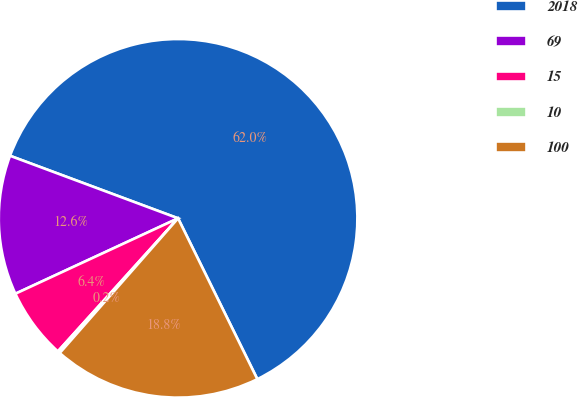Convert chart to OTSL. <chart><loc_0><loc_0><loc_500><loc_500><pie_chart><fcel>2018<fcel>69<fcel>15<fcel>10<fcel>100<nl><fcel>62.04%<fcel>12.58%<fcel>6.4%<fcel>0.22%<fcel>18.76%<nl></chart> 